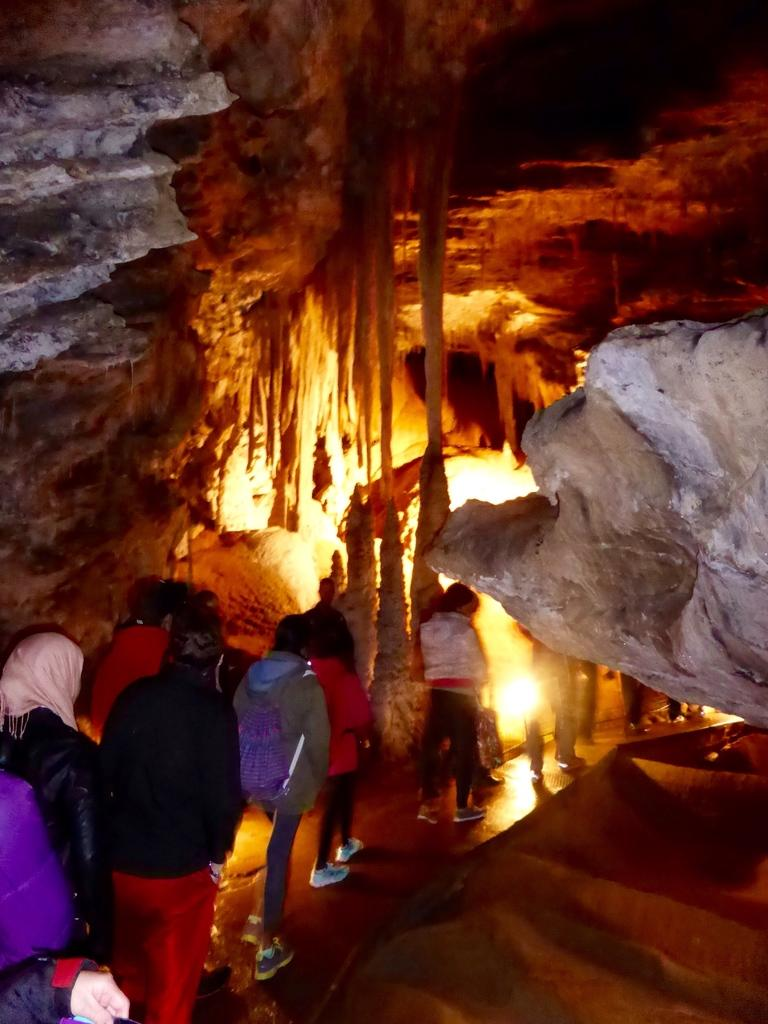Who or what can be seen in the bottom left side of the image? There are people in the bottom left side of the image. What is located in front of the people? There is a subway in front of the people. What type of natural feature is visible in the background of the image? There are rocks in the background area of the image. How many muscles can be seen flexing on the people's fingers in the image? There is no indication of muscles or fingers flexing in the image; it only shows people and a subway. 